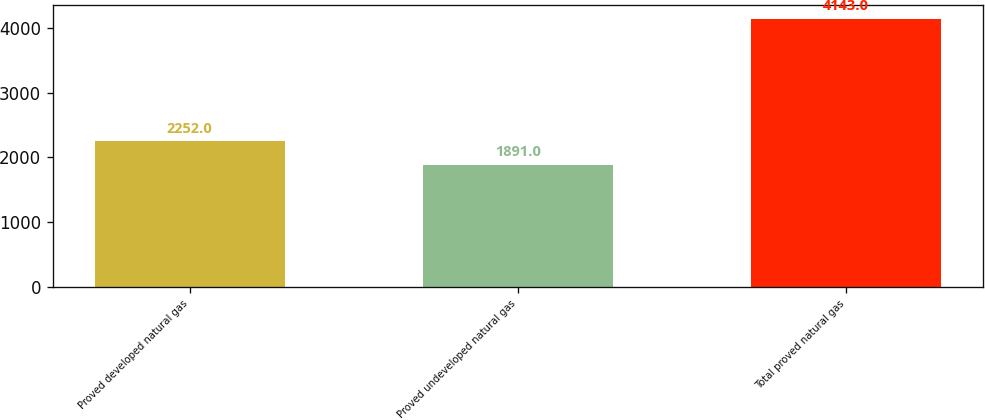<chart> <loc_0><loc_0><loc_500><loc_500><bar_chart><fcel>Proved developed natural gas<fcel>Proved undeveloped natural gas<fcel>Total proved natural gas<nl><fcel>2252<fcel>1891<fcel>4143<nl></chart> 